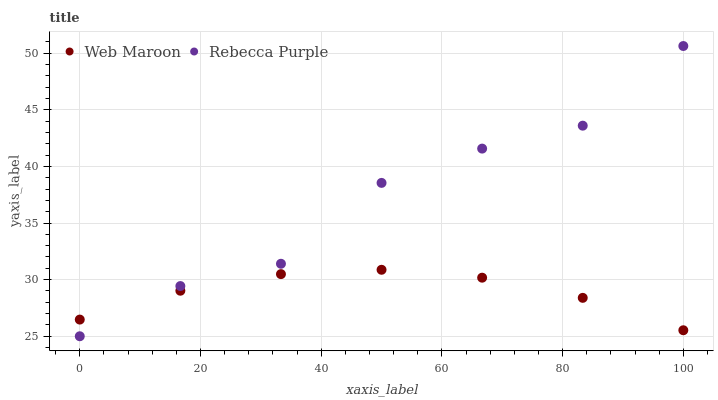Does Web Maroon have the minimum area under the curve?
Answer yes or no. Yes. Does Rebecca Purple have the maximum area under the curve?
Answer yes or no. Yes. Does Rebecca Purple have the minimum area under the curve?
Answer yes or no. No. Is Web Maroon the smoothest?
Answer yes or no. Yes. Is Rebecca Purple the roughest?
Answer yes or no. Yes. Is Rebecca Purple the smoothest?
Answer yes or no. No. Does Rebecca Purple have the lowest value?
Answer yes or no. Yes. Does Rebecca Purple have the highest value?
Answer yes or no. Yes. Does Web Maroon intersect Rebecca Purple?
Answer yes or no. Yes. Is Web Maroon less than Rebecca Purple?
Answer yes or no. No. Is Web Maroon greater than Rebecca Purple?
Answer yes or no. No. 